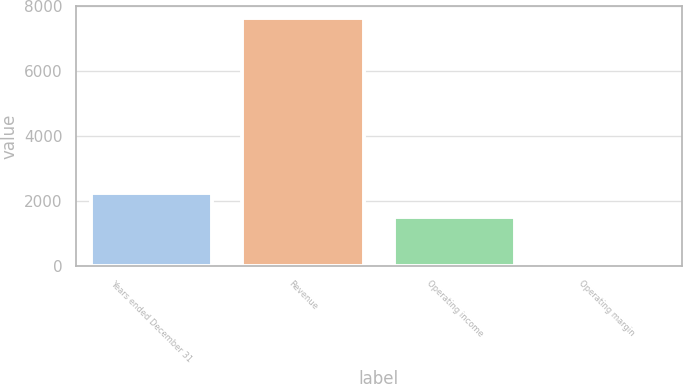Convert chart. <chart><loc_0><loc_0><loc_500><loc_500><bar_chart><fcel>Years ended December 31<fcel>Revenue<fcel>Operating income<fcel>Operating margin<nl><fcel>2254.24<fcel>7632<fcel>1493<fcel>19.6<nl></chart> 